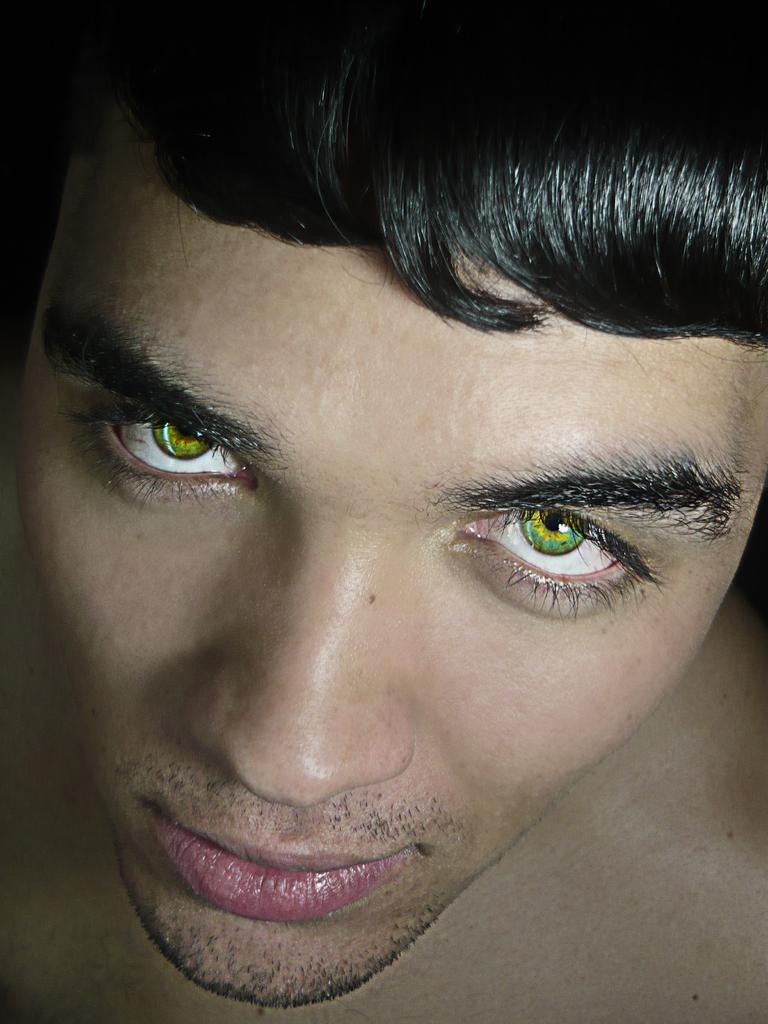How would you summarize this image in a sentence or two? In this image we can see a man. 